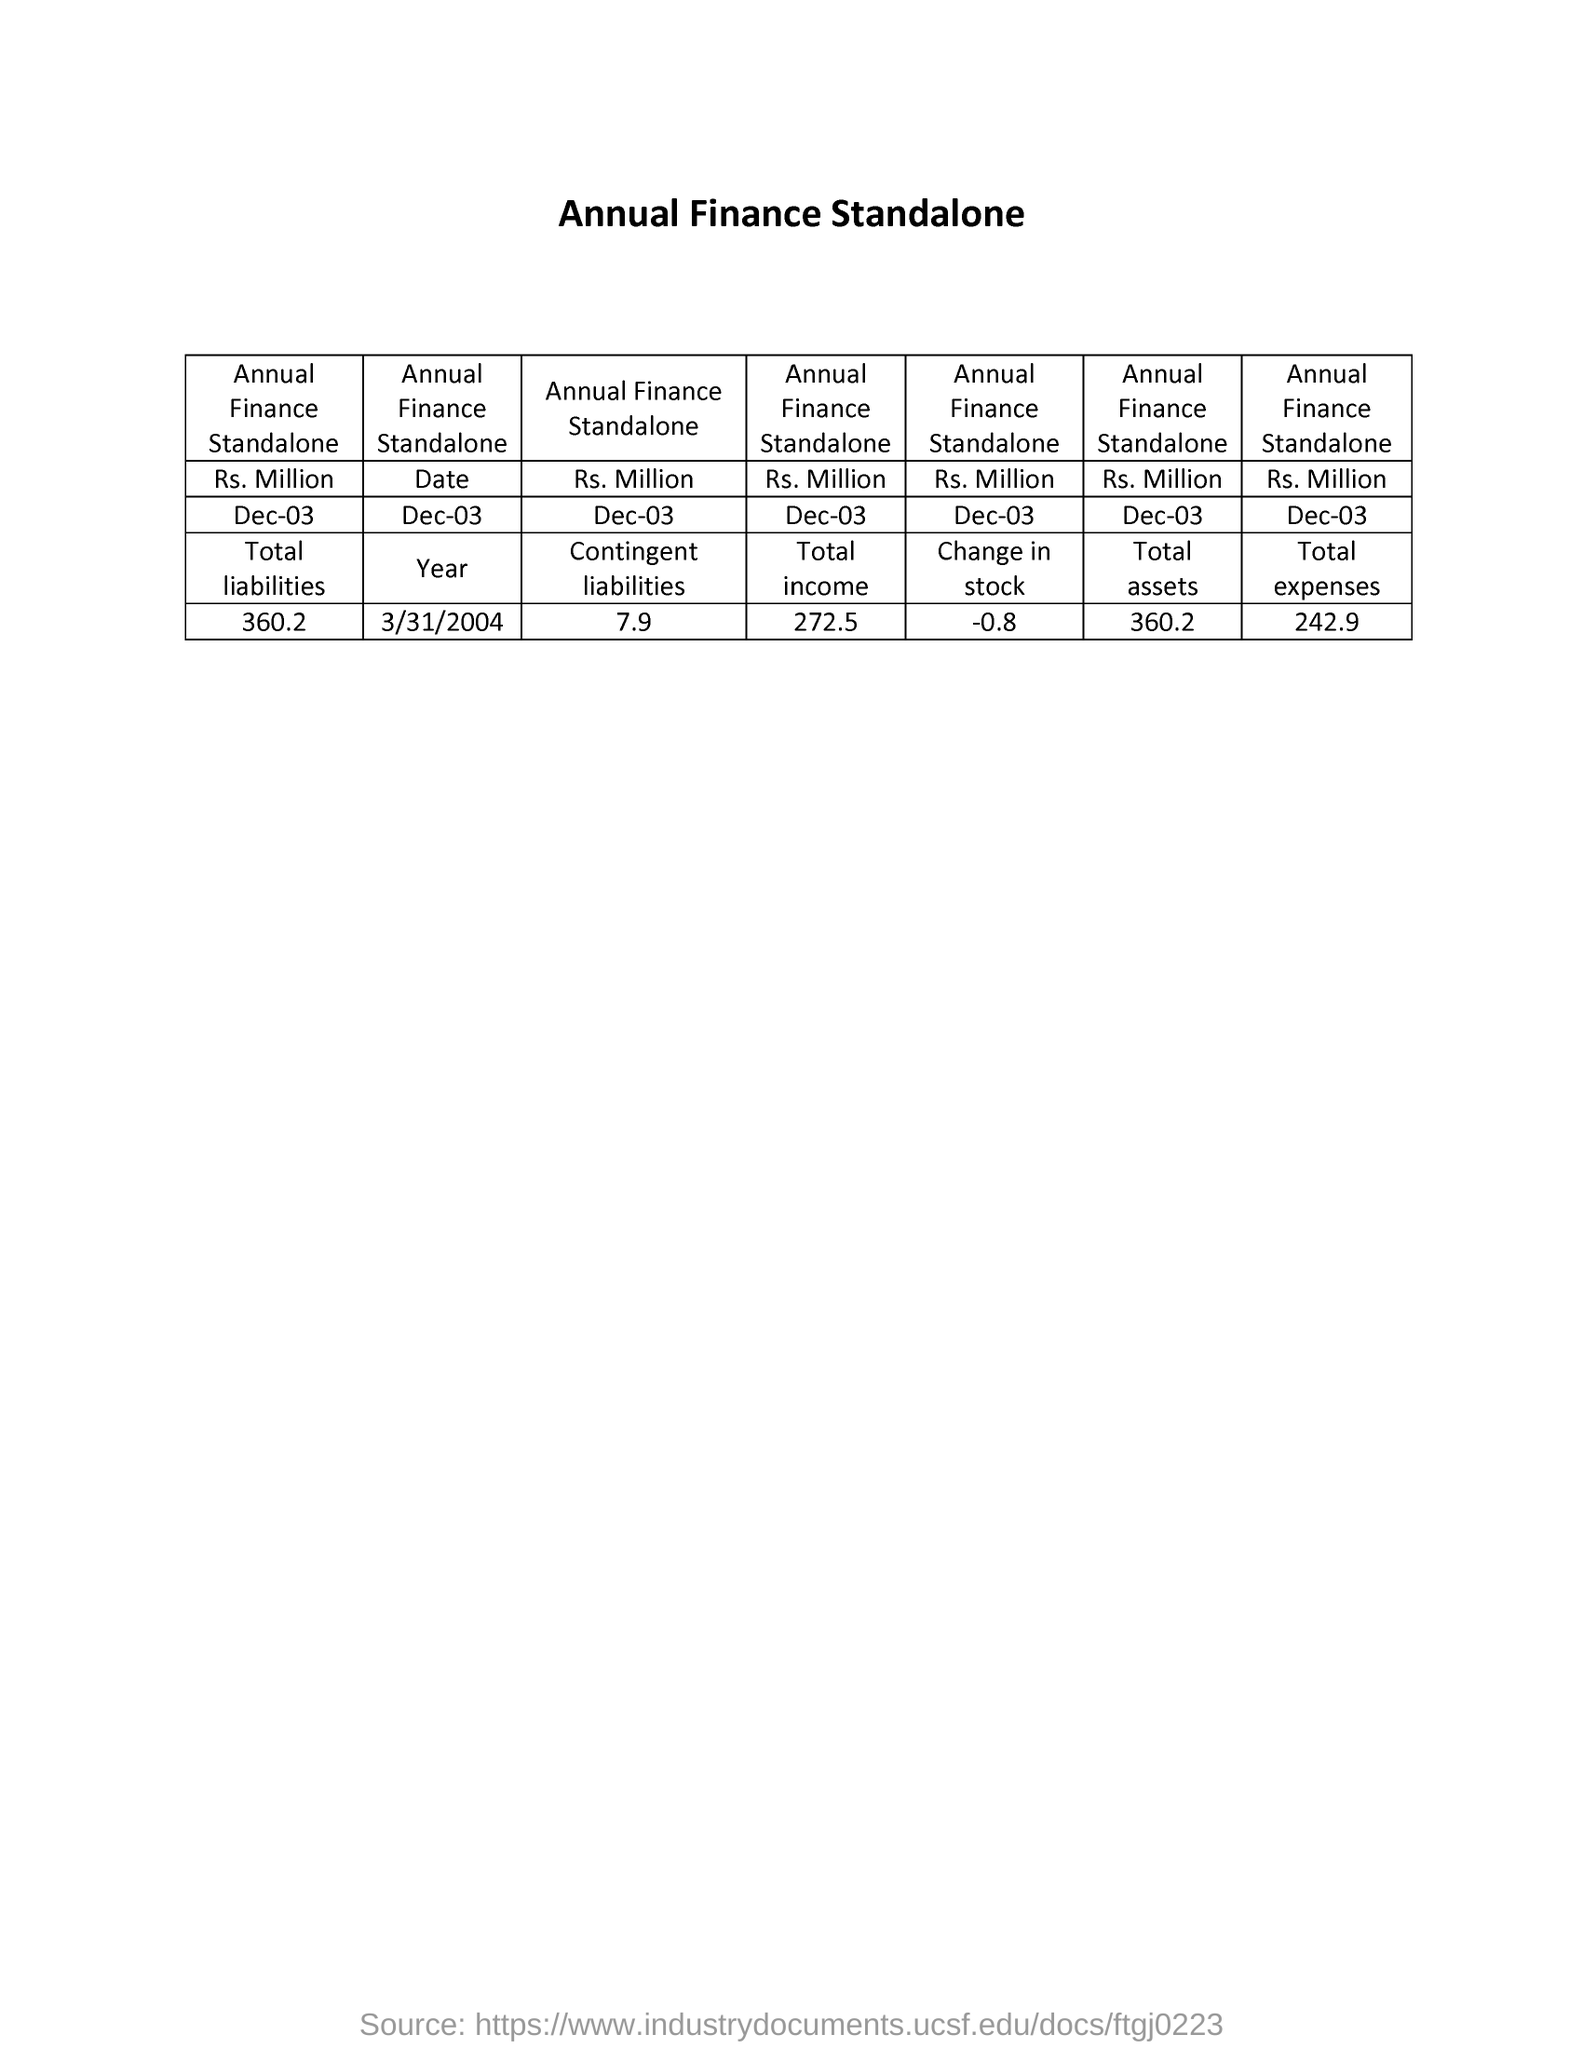Draw attention to some important aspects in this diagram. The total assets are 360.2.. The total income is 272.5. The total liability is 360.2. The total expense is 242.9 dollars. The title of the document is "Annual Finance Standalone". 